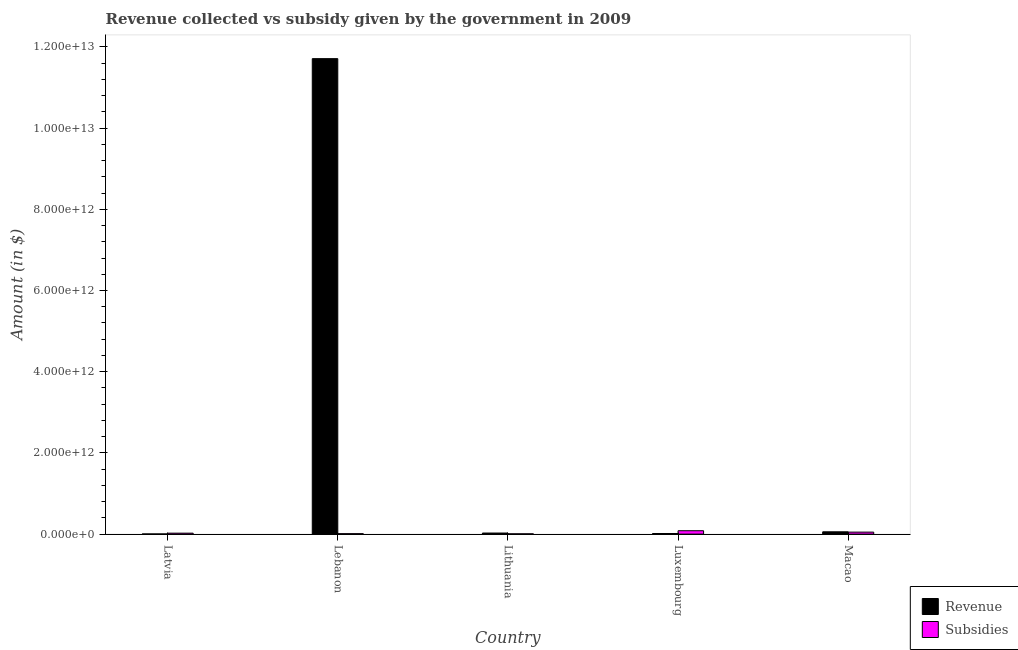How many groups of bars are there?
Offer a very short reply. 5. How many bars are there on the 5th tick from the right?
Your answer should be compact. 2. What is the label of the 4th group of bars from the left?
Your answer should be very brief. Luxembourg. What is the amount of revenue collected in Lithuania?
Your answer should be compact. 2.62e+1. Across all countries, what is the maximum amount of revenue collected?
Offer a very short reply. 1.17e+13. Across all countries, what is the minimum amount of subsidies given?
Your answer should be compact. 6.59e+09. In which country was the amount of revenue collected maximum?
Offer a very short reply. Lebanon. In which country was the amount of subsidies given minimum?
Give a very brief answer. Lithuania. What is the total amount of revenue collected in the graph?
Make the answer very short. 1.18e+13. What is the difference between the amount of subsidies given in Latvia and that in Macao?
Give a very brief answer. -2.59e+1. What is the difference between the amount of revenue collected in Macao and the amount of subsidies given in Lithuania?
Your answer should be compact. 5.01e+1. What is the average amount of revenue collected per country?
Provide a succinct answer. 2.36e+12. What is the difference between the amount of revenue collected and amount of subsidies given in Lithuania?
Offer a terse response. 1.96e+1. In how many countries, is the amount of subsidies given greater than 1600000000000 $?
Your answer should be compact. 0. What is the ratio of the amount of revenue collected in Lithuania to that in Macao?
Provide a succinct answer. 0.46. What is the difference between the highest and the second highest amount of revenue collected?
Keep it short and to the point. 1.17e+13. What is the difference between the highest and the lowest amount of subsidies given?
Provide a short and direct response. 7.65e+1. Is the sum of the amount of subsidies given in Lebanon and Lithuania greater than the maximum amount of revenue collected across all countries?
Your response must be concise. No. What does the 2nd bar from the left in Macao represents?
Ensure brevity in your answer.  Subsidies. What does the 2nd bar from the right in Macao represents?
Your response must be concise. Revenue. How many bars are there?
Offer a terse response. 10. How many countries are there in the graph?
Your response must be concise. 5. What is the difference between two consecutive major ticks on the Y-axis?
Offer a terse response. 2.00e+12. Are the values on the major ticks of Y-axis written in scientific E-notation?
Make the answer very short. Yes. Does the graph contain any zero values?
Make the answer very short. No. What is the title of the graph?
Provide a succinct answer. Revenue collected vs subsidy given by the government in 2009. What is the label or title of the X-axis?
Keep it short and to the point. Country. What is the label or title of the Y-axis?
Keep it short and to the point. Amount (in $). What is the Amount (in $) in Revenue in Latvia?
Your answer should be compact. 3.39e+09. What is the Amount (in $) in Subsidies in Latvia?
Make the answer very short. 2.32e+1. What is the Amount (in $) in Revenue in Lebanon?
Offer a very short reply. 1.17e+13. What is the Amount (in $) of Subsidies in Lebanon?
Your answer should be compact. 1.03e+1. What is the Amount (in $) of Revenue in Lithuania?
Provide a short and direct response. 2.62e+1. What is the Amount (in $) of Subsidies in Lithuania?
Ensure brevity in your answer.  6.59e+09. What is the Amount (in $) of Revenue in Luxembourg?
Your answer should be compact. 1.47e+1. What is the Amount (in $) in Subsidies in Luxembourg?
Make the answer very short. 8.31e+1. What is the Amount (in $) in Revenue in Macao?
Your response must be concise. 5.67e+1. What is the Amount (in $) in Subsidies in Macao?
Give a very brief answer. 4.91e+1. Across all countries, what is the maximum Amount (in $) of Revenue?
Offer a terse response. 1.17e+13. Across all countries, what is the maximum Amount (in $) in Subsidies?
Ensure brevity in your answer.  8.31e+1. Across all countries, what is the minimum Amount (in $) in Revenue?
Your answer should be compact. 3.39e+09. Across all countries, what is the minimum Amount (in $) in Subsidies?
Your answer should be compact. 6.59e+09. What is the total Amount (in $) of Revenue in the graph?
Ensure brevity in your answer.  1.18e+13. What is the total Amount (in $) in Subsidies in the graph?
Offer a terse response. 1.72e+11. What is the difference between the Amount (in $) of Revenue in Latvia and that in Lebanon?
Your answer should be compact. -1.17e+13. What is the difference between the Amount (in $) in Subsidies in Latvia and that in Lebanon?
Ensure brevity in your answer.  1.29e+1. What is the difference between the Amount (in $) of Revenue in Latvia and that in Lithuania?
Ensure brevity in your answer.  -2.28e+1. What is the difference between the Amount (in $) in Subsidies in Latvia and that in Lithuania?
Offer a terse response. 1.66e+1. What is the difference between the Amount (in $) of Revenue in Latvia and that in Luxembourg?
Ensure brevity in your answer.  -1.13e+1. What is the difference between the Amount (in $) in Subsidies in Latvia and that in Luxembourg?
Your answer should be compact. -5.99e+1. What is the difference between the Amount (in $) of Revenue in Latvia and that in Macao?
Keep it short and to the point. -5.33e+1. What is the difference between the Amount (in $) in Subsidies in Latvia and that in Macao?
Make the answer very short. -2.59e+1. What is the difference between the Amount (in $) of Revenue in Lebanon and that in Lithuania?
Provide a short and direct response. 1.17e+13. What is the difference between the Amount (in $) in Subsidies in Lebanon and that in Lithuania?
Offer a very short reply. 3.69e+09. What is the difference between the Amount (in $) in Revenue in Lebanon and that in Luxembourg?
Give a very brief answer. 1.17e+13. What is the difference between the Amount (in $) of Subsidies in Lebanon and that in Luxembourg?
Keep it short and to the point. -7.28e+1. What is the difference between the Amount (in $) of Revenue in Lebanon and that in Macao?
Provide a succinct answer. 1.17e+13. What is the difference between the Amount (in $) of Subsidies in Lebanon and that in Macao?
Your answer should be compact. -3.88e+1. What is the difference between the Amount (in $) in Revenue in Lithuania and that in Luxembourg?
Keep it short and to the point. 1.15e+1. What is the difference between the Amount (in $) in Subsidies in Lithuania and that in Luxembourg?
Ensure brevity in your answer.  -7.65e+1. What is the difference between the Amount (in $) of Revenue in Lithuania and that in Macao?
Your answer should be compact. -3.05e+1. What is the difference between the Amount (in $) of Subsidies in Lithuania and that in Macao?
Keep it short and to the point. -4.25e+1. What is the difference between the Amount (in $) of Revenue in Luxembourg and that in Macao?
Ensure brevity in your answer.  -4.20e+1. What is the difference between the Amount (in $) in Subsidies in Luxembourg and that in Macao?
Your answer should be very brief. 3.40e+1. What is the difference between the Amount (in $) of Revenue in Latvia and the Amount (in $) of Subsidies in Lebanon?
Ensure brevity in your answer.  -6.89e+09. What is the difference between the Amount (in $) of Revenue in Latvia and the Amount (in $) of Subsidies in Lithuania?
Offer a terse response. -3.20e+09. What is the difference between the Amount (in $) in Revenue in Latvia and the Amount (in $) in Subsidies in Luxembourg?
Provide a short and direct response. -7.97e+1. What is the difference between the Amount (in $) in Revenue in Latvia and the Amount (in $) in Subsidies in Macao?
Provide a short and direct response. -4.57e+1. What is the difference between the Amount (in $) in Revenue in Lebanon and the Amount (in $) in Subsidies in Lithuania?
Your response must be concise. 1.17e+13. What is the difference between the Amount (in $) in Revenue in Lebanon and the Amount (in $) in Subsidies in Luxembourg?
Offer a terse response. 1.16e+13. What is the difference between the Amount (in $) of Revenue in Lebanon and the Amount (in $) of Subsidies in Macao?
Offer a terse response. 1.17e+13. What is the difference between the Amount (in $) in Revenue in Lithuania and the Amount (in $) in Subsidies in Luxembourg?
Give a very brief answer. -5.69e+1. What is the difference between the Amount (in $) in Revenue in Lithuania and the Amount (in $) in Subsidies in Macao?
Provide a succinct answer. -2.29e+1. What is the difference between the Amount (in $) of Revenue in Luxembourg and the Amount (in $) of Subsidies in Macao?
Make the answer very short. -3.44e+1. What is the average Amount (in $) of Revenue per country?
Make the answer very short. 2.36e+12. What is the average Amount (in $) in Subsidies per country?
Offer a terse response. 3.44e+1. What is the difference between the Amount (in $) in Revenue and Amount (in $) in Subsidies in Latvia?
Your response must be concise. -1.98e+1. What is the difference between the Amount (in $) in Revenue and Amount (in $) in Subsidies in Lebanon?
Make the answer very short. 1.17e+13. What is the difference between the Amount (in $) of Revenue and Amount (in $) of Subsidies in Lithuania?
Offer a very short reply. 1.96e+1. What is the difference between the Amount (in $) in Revenue and Amount (in $) in Subsidies in Luxembourg?
Provide a short and direct response. -6.84e+1. What is the difference between the Amount (in $) of Revenue and Amount (in $) of Subsidies in Macao?
Offer a very short reply. 7.58e+09. What is the ratio of the Amount (in $) in Subsidies in Latvia to that in Lebanon?
Make the answer very short. 2.25. What is the ratio of the Amount (in $) in Revenue in Latvia to that in Lithuania?
Give a very brief answer. 0.13. What is the ratio of the Amount (in $) of Subsidies in Latvia to that in Lithuania?
Your response must be concise. 3.52. What is the ratio of the Amount (in $) in Revenue in Latvia to that in Luxembourg?
Offer a terse response. 0.23. What is the ratio of the Amount (in $) in Subsidies in Latvia to that in Luxembourg?
Make the answer very short. 0.28. What is the ratio of the Amount (in $) in Revenue in Latvia to that in Macao?
Provide a succinct answer. 0.06. What is the ratio of the Amount (in $) in Subsidies in Latvia to that in Macao?
Give a very brief answer. 0.47. What is the ratio of the Amount (in $) of Revenue in Lebanon to that in Lithuania?
Provide a short and direct response. 447.23. What is the ratio of the Amount (in $) of Subsidies in Lebanon to that in Lithuania?
Ensure brevity in your answer.  1.56. What is the ratio of the Amount (in $) of Revenue in Lebanon to that in Luxembourg?
Your response must be concise. 797.38. What is the ratio of the Amount (in $) in Subsidies in Lebanon to that in Luxembourg?
Make the answer very short. 0.12. What is the ratio of the Amount (in $) of Revenue in Lebanon to that in Macao?
Provide a short and direct response. 206.64. What is the ratio of the Amount (in $) of Subsidies in Lebanon to that in Macao?
Your answer should be compact. 0.21. What is the ratio of the Amount (in $) in Revenue in Lithuania to that in Luxembourg?
Provide a short and direct response. 1.78. What is the ratio of the Amount (in $) in Subsidies in Lithuania to that in Luxembourg?
Your answer should be compact. 0.08. What is the ratio of the Amount (in $) in Revenue in Lithuania to that in Macao?
Your answer should be compact. 0.46. What is the ratio of the Amount (in $) of Subsidies in Lithuania to that in Macao?
Your response must be concise. 0.13. What is the ratio of the Amount (in $) in Revenue in Luxembourg to that in Macao?
Provide a succinct answer. 0.26. What is the ratio of the Amount (in $) in Subsidies in Luxembourg to that in Macao?
Provide a succinct answer. 1.69. What is the difference between the highest and the second highest Amount (in $) in Revenue?
Make the answer very short. 1.17e+13. What is the difference between the highest and the second highest Amount (in $) of Subsidies?
Your answer should be very brief. 3.40e+1. What is the difference between the highest and the lowest Amount (in $) of Revenue?
Your answer should be very brief. 1.17e+13. What is the difference between the highest and the lowest Amount (in $) in Subsidies?
Your answer should be compact. 7.65e+1. 